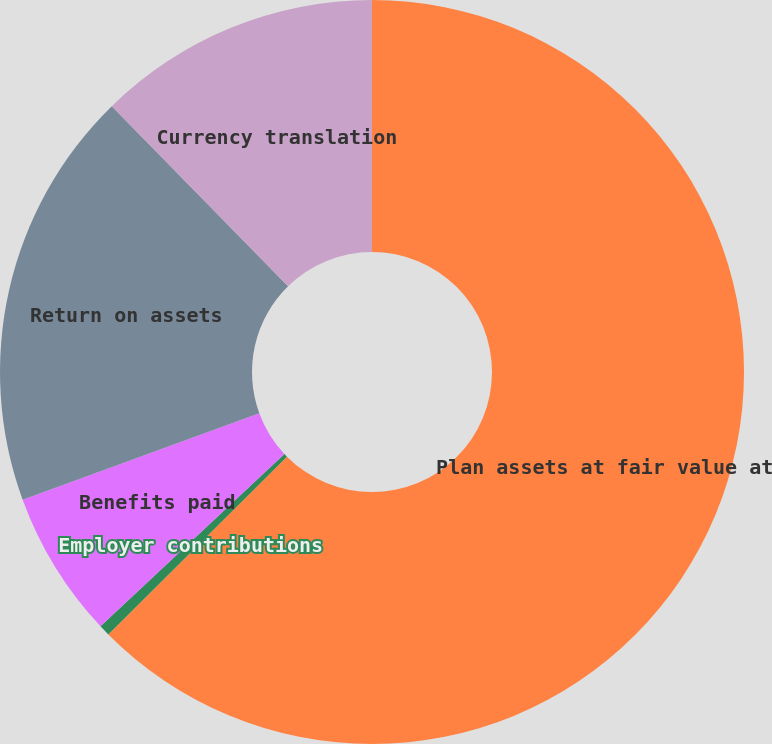Convert chart. <chart><loc_0><loc_0><loc_500><loc_500><pie_chart><fcel>Plan assets at fair value at<fcel>Employer contributions<fcel>Benefits paid<fcel>Return on assets<fcel>Currency translation<nl><fcel>62.54%<fcel>0.48%<fcel>6.4%<fcel>18.25%<fcel>12.33%<nl></chart> 